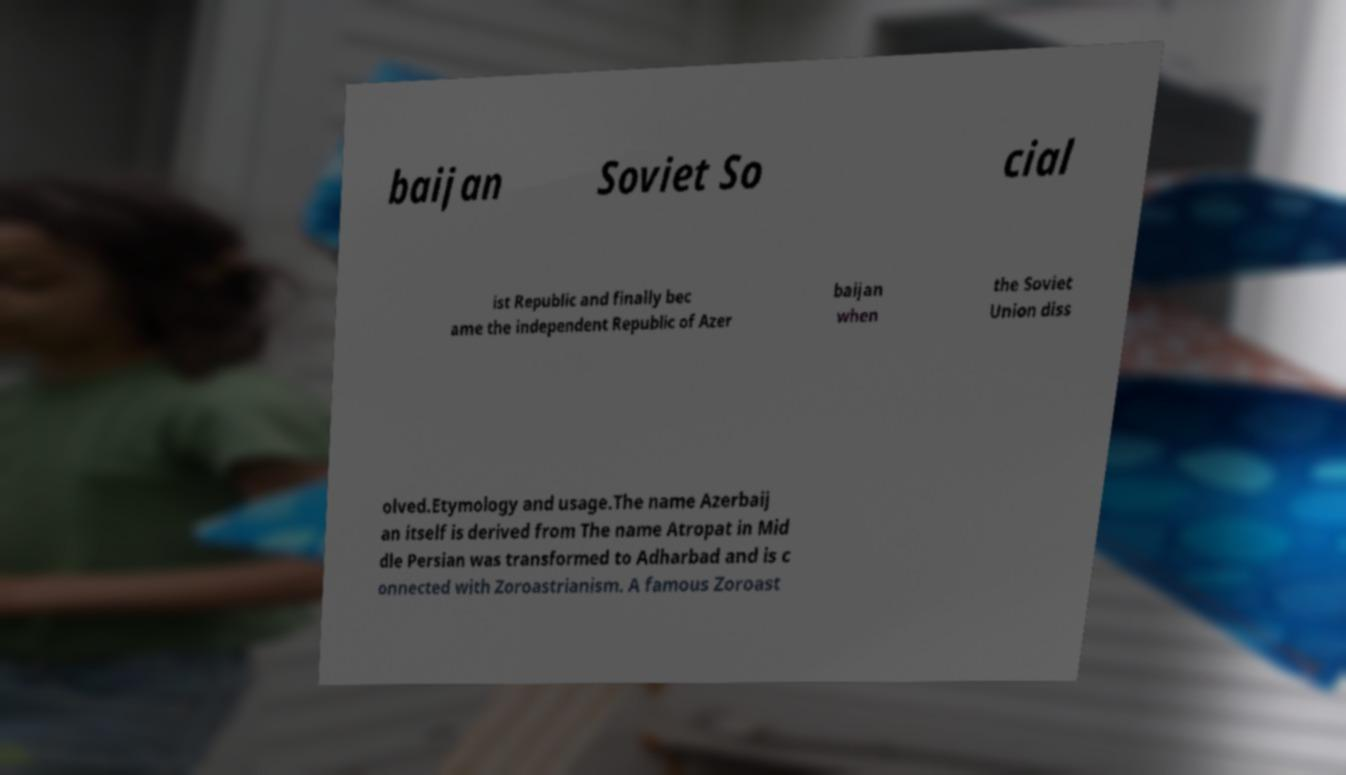Please read and relay the text visible in this image. What does it say? baijan Soviet So cial ist Republic and finally bec ame the independent Republic of Azer baijan when the Soviet Union diss olved.Etymology and usage.The name Azerbaij an itself is derived from The name Atropat in Mid dle Persian was transformed to Adharbad and is c onnected with Zoroastrianism. A famous Zoroast 